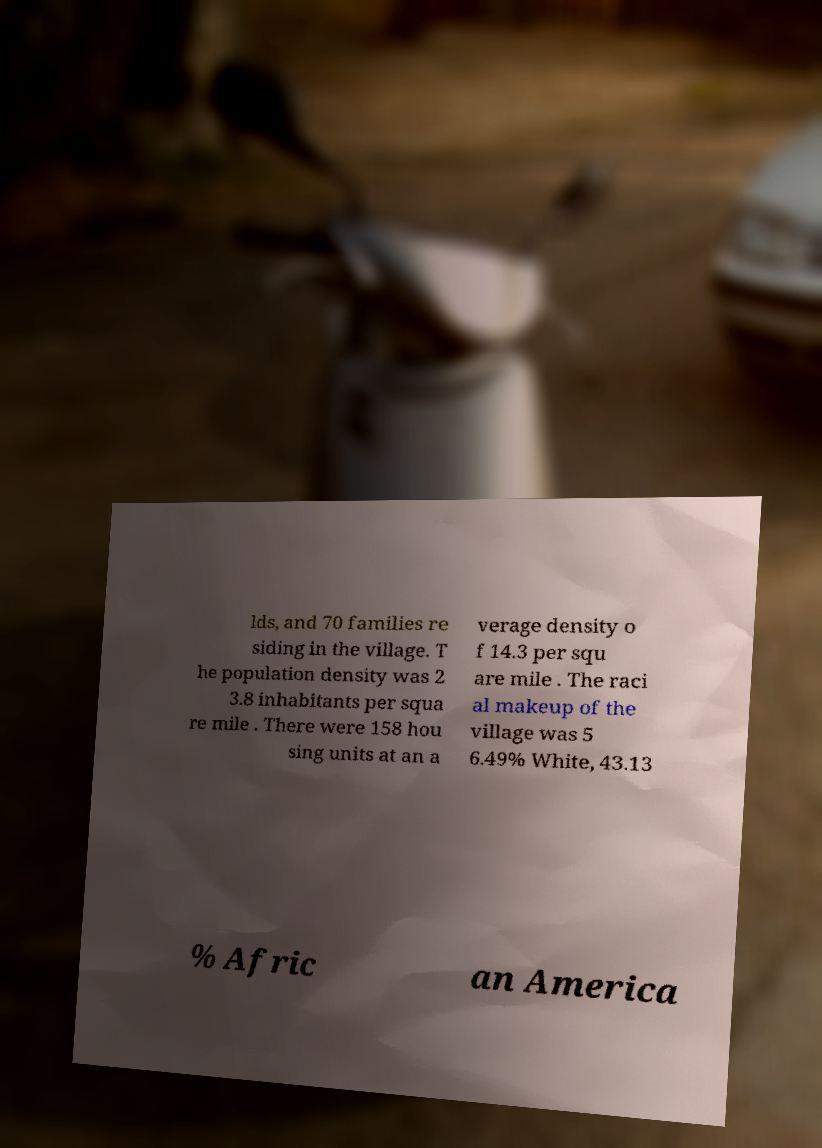What messages or text are displayed in this image? I need them in a readable, typed format. lds, and 70 families re siding in the village. T he population density was 2 3.8 inhabitants per squa re mile . There were 158 hou sing units at an a verage density o f 14.3 per squ are mile . The raci al makeup of the village was 5 6.49% White, 43.13 % Afric an America 